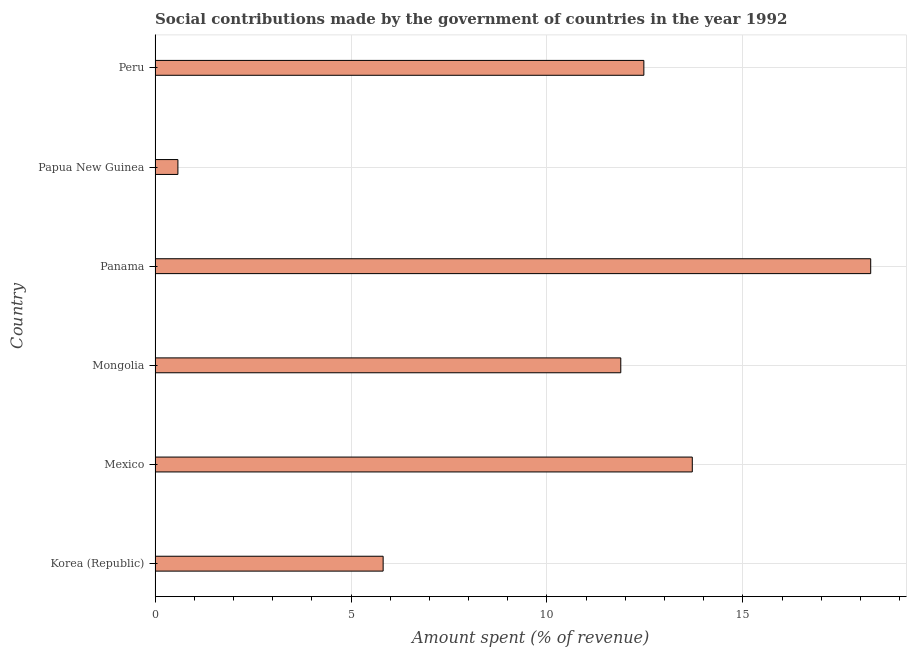Does the graph contain any zero values?
Ensure brevity in your answer.  No. What is the title of the graph?
Give a very brief answer. Social contributions made by the government of countries in the year 1992. What is the label or title of the X-axis?
Make the answer very short. Amount spent (% of revenue). What is the label or title of the Y-axis?
Ensure brevity in your answer.  Country. What is the amount spent in making social contributions in Panama?
Your answer should be compact. 18.26. Across all countries, what is the maximum amount spent in making social contributions?
Give a very brief answer. 18.26. Across all countries, what is the minimum amount spent in making social contributions?
Provide a succinct answer. 0.58. In which country was the amount spent in making social contributions maximum?
Ensure brevity in your answer.  Panama. In which country was the amount spent in making social contributions minimum?
Provide a short and direct response. Papua New Guinea. What is the sum of the amount spent in making social contributions?
Offer a terse response. 62.73. What is the difference between the amount spent in making social contributions in Mexico and Mongolia?
Offer a terse response. 1.82. What is the average amount spent in making social contributions per country?
Provide a short and direct response. 10.46. What is the median amount spent in making social contributions?
Ensure brevity in your answer.  12.18. What is the ratio of the amount spent in making social contributions in Mongolia to that in Papua New Guinea?
Keep it short and to the point. 20.39. Is the amount spent in making social contributions in Mongolia less than that in Papua New Guinea?
Your answer should be compact. No. What is the difference between the highest and the second highest amount spent in making social contributions?
Make the answer very short. 4.55. Is the sum of the amount spent in making social contributions in Panama and Papua New Guinea greater than the maximum amount spent in making social contributions across all countries?
Ensure brevity in your answer.  Yes. What is the difference between the highest and the lowest amount spent in making social contributions?
Your answer should be very brief. 17.68. In how many countries, is the amount spent in making social contributions greater than the average amount spent in making social contributions taken over all countries?
Offer a very short reply. 4. How many bars are there?
Ensure brevity in your answer.  6. What is the Amount spent (% of revenue) of Korea (Republic)?
Offer a very short reply. 5.82. What is the Amount spent (% of revenue) of Mexico?
Give a very brief answer. 13.71. What is the Amount spent (% of revenue) of Mongolia?
Your answer should be very brief. 11.88. What is the Amount spent (% of revenue) in Panama?
Offer a terse response. 18.26. What is the Amount spent (% of revenue) in Papua New Guinea?
Your response must be concise. 0.58. What is the Amount spent (% of revenue) in Peru?
Keep it short and to the point. 12.47. What is the difference between the Amount spent (% of revenue) in Korea (Republic) and Mexico?
Offer a very short reply. -7.89. What is the difference between the Amount spent (% of revenue) in Korea (Republic) and Mongolia?
Your answer should be compact. -6.06. What is the difference between the Amount spent (% of revenue) in Korea (Republic) and Panama?
Offer a very short reply. -12.44. What is the difference between the Amount spent (% of revenue) in Korea (Republic) and Papua New Guinea?
Offer a very short reply. 5.24. What is the difference between the Amount spent (% of revenue) in Korea (Republic) and Peru?
Offer a terse response. -6.65. What is the difference between the Amount spent (% of revenue) in Mexico and Mongolia?
Offer a terse response. 1.82. What is the difference between the Amount spent (% of revenue) in Mexico and Panama?
Make the answer very short. -4.55. What is the difference between the Amount spent (% of revenue) in Mexico and Papua New Guinea?
Offer a very short reply. 13.13. What is the difference between the Amount spent (% of revenue) in Mexico and Peru?
Give a very brief answer. 1.24. What is the difference between the Amount spent (% of revenue) in Mongolia and Panama?
Make the answer very short. -6.38. What is the difference between the Amount spent (% of revenue) in Mongolia and Papua New Guinea?
Offer a very short reply. 11.3. What is the difference between the Amount spent (% of revenue) in Mongolia and Peru?
Make the answer very short. -0.59. What is the difference between the Amount spent (% of revenue) in Panama and Papua New Guinea?
Give a very brief answer. 17.68. What is the difference between the Amount spent (% of revenue) in Panama and Peru?
Provide a succinct answer. 5.79. What is the difference between the Amount spent (% of revenue) in Papua New Guinea and Peru?
Provide a succinct answer. -11.89. What is the ratio of the Amount spent (% of revenue) in Korea (Republic) to that in Mexico?
Your response must be concise. 0.42. What is the ratio of the Amount spent (% of revenue) in Korea (Republic) to that in Mongolia?
Make the answer very short. 0.49. What is the ratio of the Amount spent (% of revenue) in Korea (Republic) to that in Panama?
Offer a very short reply. 0.32. What is the ratio of the Amount spent (% of revenue) in Korea (Republic) to that in Papua New Guinea?
Your answer should be very brief. 9.98. What is the ratio of the Amount spent (% of revenue) in Korea (Republic) to that in Peru?
Your answer should be compact. 0.47. What is the ratio of the Amount spent (% of revenue) in Mexico to that in Mongolia?
Keep it short and to the point. 1.15. What is the ratio of the Amount spent (% of revenue) in Mexico to that in Panama?
Make the answer very short. 0.75. What is the ratio of the Amount spent (% of revenue) in Mexico to that in Papua New Guinea?
Ensure brevity in your answer.  23.52. What is the ratio of the Amount spent (% of revenue) in Mexico to that in Peru?
Your answer should be very brief. 1.1. What is the ratio of the Amount spent (% of revenue) in Mongolia to that in Panama?
Provide a short and direct response. 0.65. What is the ratio of the Amount spent (% of revenue) in Mongolia to that in Papua New Guinea?
Your response must be concise. 20.39. What is the ratio of the Amount spent (% of revenue) in Mongolia to that in Peru?
Make the answer very short. 0.95. What is the ratio of the Amount spent (% of revenue) in Panama to that in Papua New Guinea?
Ensure brevity in your answer.  31.32. What is the ratio of the Amount spent (% of revenue) in Panama to that in Peru?
Keep it short and to the point. 1.46. What is the ratio of the Amount spent (% of revenue) in Papua New Guinea to that in Peru?
Offer a terse response. 0.05. 